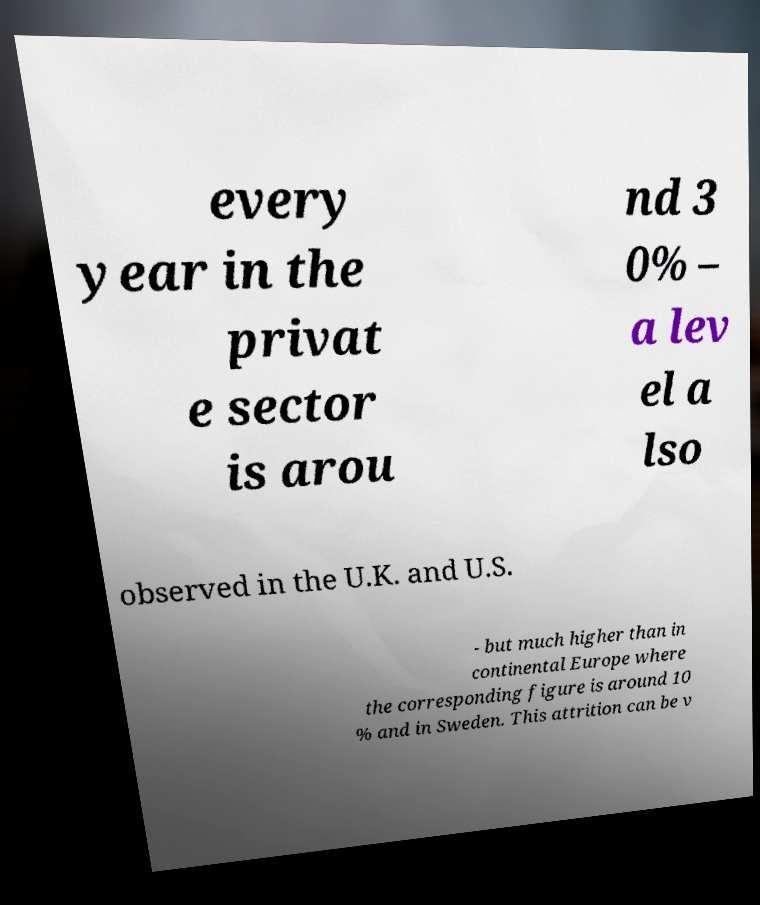Can you read and provide the text displayed in the image?This photo seems to have some interesting text. Can you extract and type it out for me? every year in the privat e sector is arou nd 3 0% – a lev el a lso observed in the U.K. and U.S. - but much higher than in continental Europe where the corresponding figure is around 10 % and in Sweden. This attrition can be v 